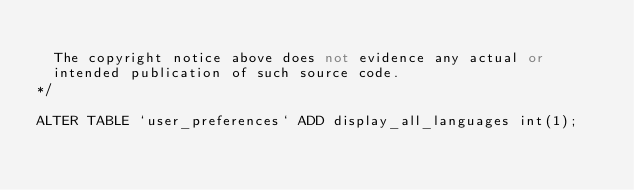Convert code to text. <code><loc_0><loc_0><loc_500><loc_500><_SQL_>
  The copyright notice above does not evidence any actual or
  intended publication of such source code.
*/

ALTER TABLE `user_preferences` ADD display_all_languages int(1);</code> 